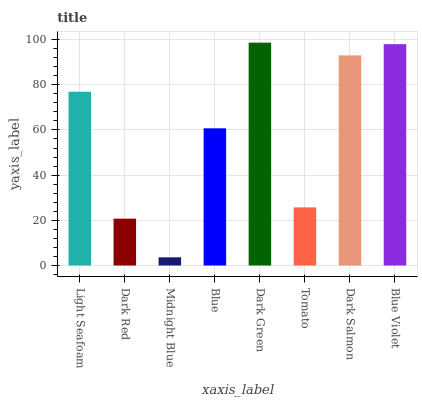Is Midnight Blue the minimum?
Answer yes or no. Yes. Is Dark Green the maximum?
Answer yes or no. Yes. Is Dark Red the minimum?
Answer yes or no. No. Is Dark Red the maximum?
Answer yes or no. No. Is Light Seafoam greater than Dark Red?
Answer yes or no. Yes. Is Dark Red less than Light Seafoam?
Answer yes or no. Yes. Is Dark Red greater than Light Seafoam?
Answer yes or no. No. Is Light Seafoam less than Dark Red?
Answer yes or no. No. Is Light Seafoam the high median?
Answer yes or no. Yes. Is Blue the low median?
Answer yes or no. Yes. Is Dark Green the high median?
Answer yes or no. No. Is Tomato the low median?
Answer yes or no. No. 